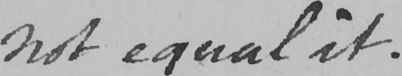Can you tell me what this handwritten text says? not equal it . 